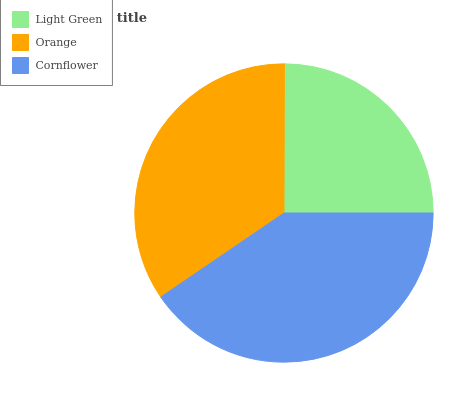Is Light Green the minimum?
Answer yes or no. Yes. Is Cornflower the maximum?
Answer yes or no. Yes. Is Orange the minimum?
Answer yes or no. No. Is Orange the maximum?
Answer yes or no. No. Is Orange greater than Light Green?
Answer yes or no. Yes. Is Light Green less than Orange?
Answer yes or no. Yes. Is Light Green greater than Orange?
Answer yes or no. No. Is Orange less than Light Green?
Answer yes or no. No. Is Orange the high median?
Answer yes or no. Yes. Is Orange the low median?
Answer yes or no. Yes. Is Cornflower the high median?
Answer yes or no. No. Is Cornflower the low median?
Answer yes or no. No. 